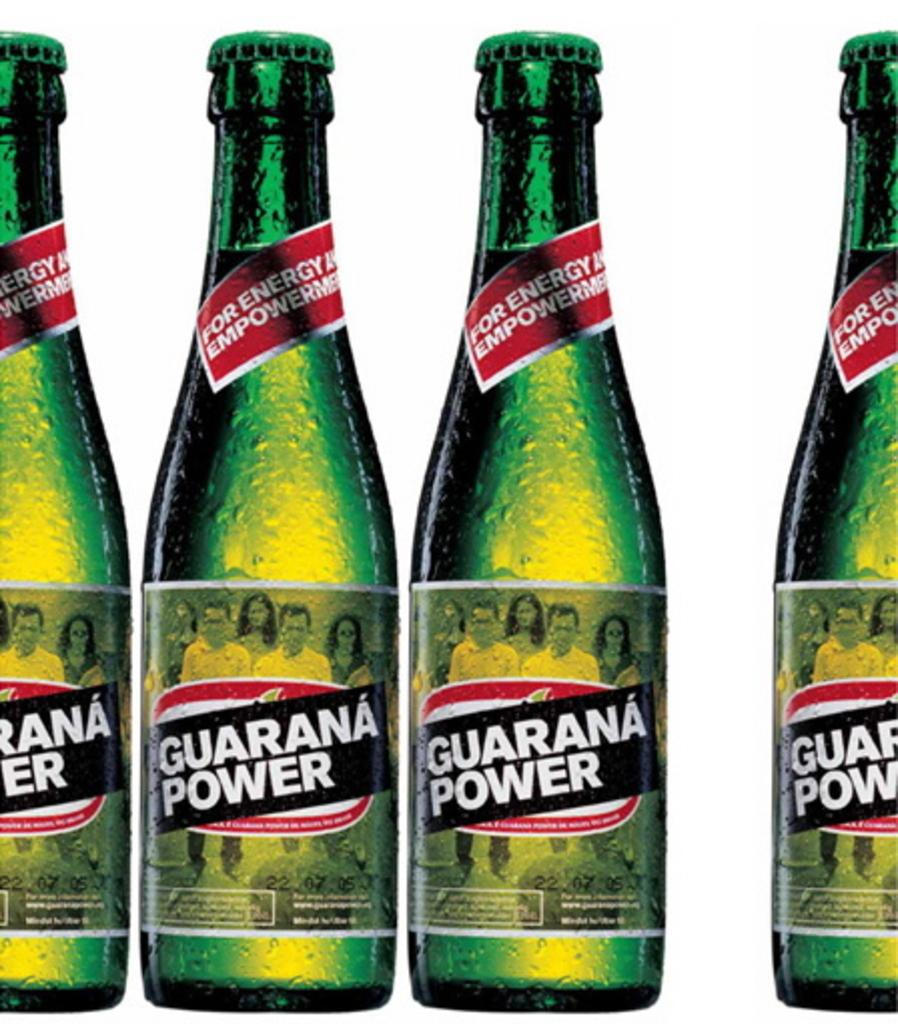<image>
Give a short and clear explanation of the subsequent image. The drink shown advertised that it is for energy. 